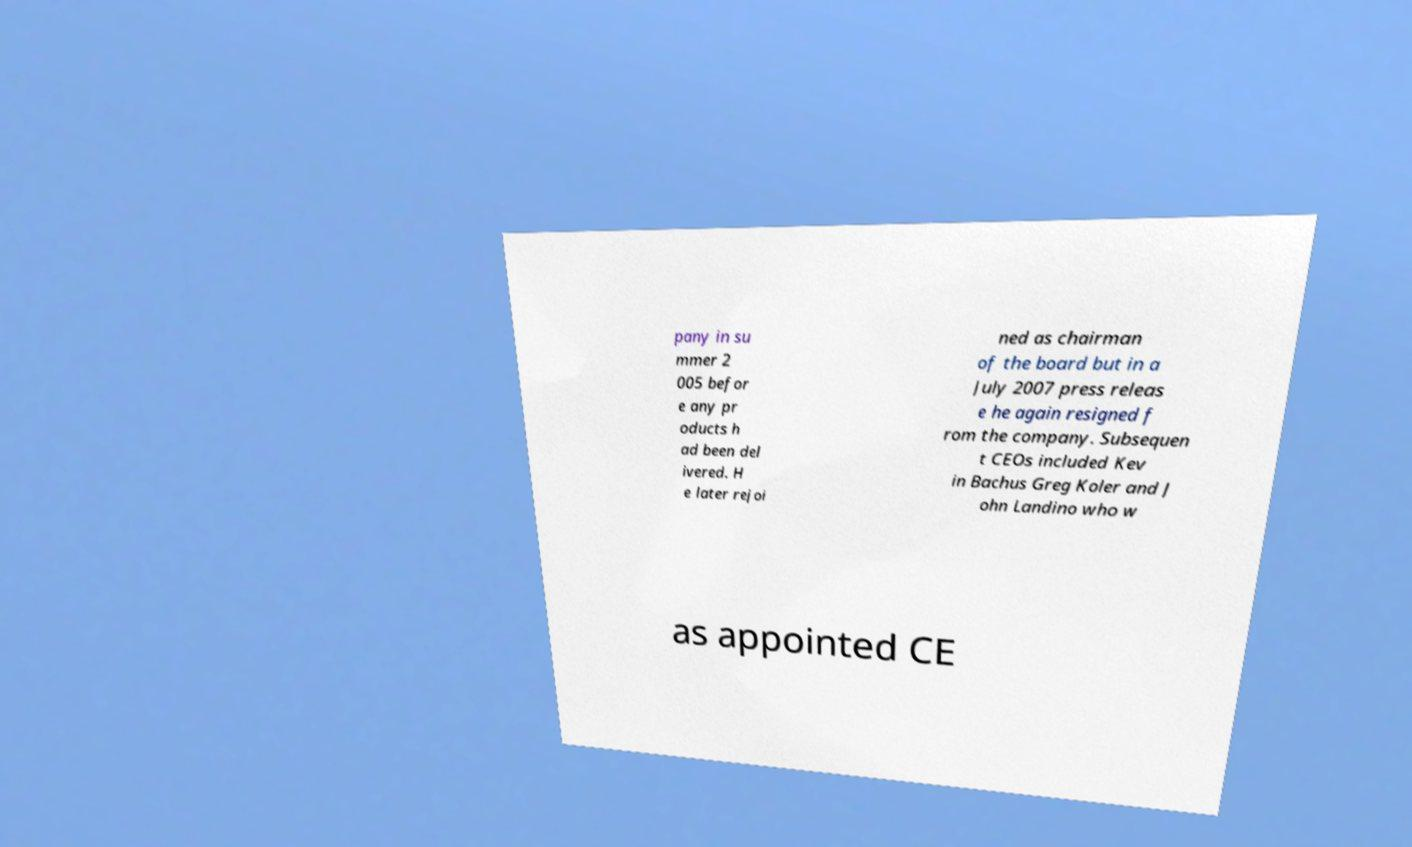What messages or text are displayed in this image? I need them in a readable, typed format. pany in su mmer 2 005 befor e any pr oducts h ad been del ivered. H e later rejoi ned as chairman of the board but in a July 2007 press releas e he again resigned f rom the company. Subsequen t CEOs included Kev in Bachus Greg Koler and J ohn Landino who w as appointed CE 